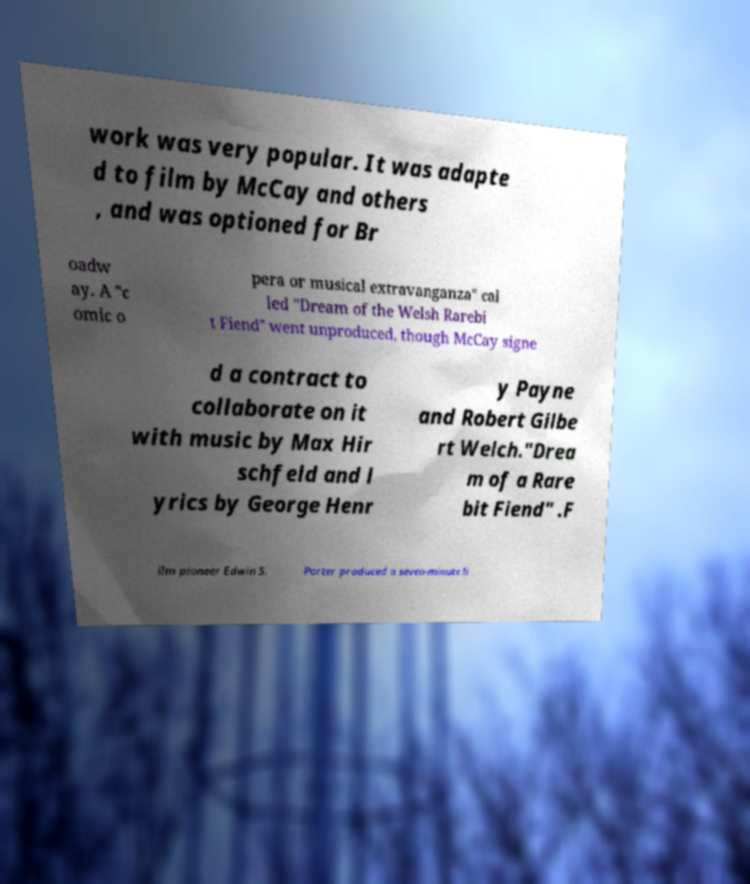For documentation purposes, I need the text within this image transcribed. Could you provide that? work was very popular. It was adapte d to film by McCay and others , and was optioned for Br oadw ay. A "c omic o pera or musical extravanganza" cal led "Dream of the Welsh Rarebi t Fiend" went unproduced, though McCay signe d a contract to collaborate on it with music by Max Hir schfeld and l yrics by George Henr y Payne and Robert Gilbe rt Welch."Drea m of a Rare bit Fiend" .F ilm pioneer Edwin S. Porter produced a seven-minute li 